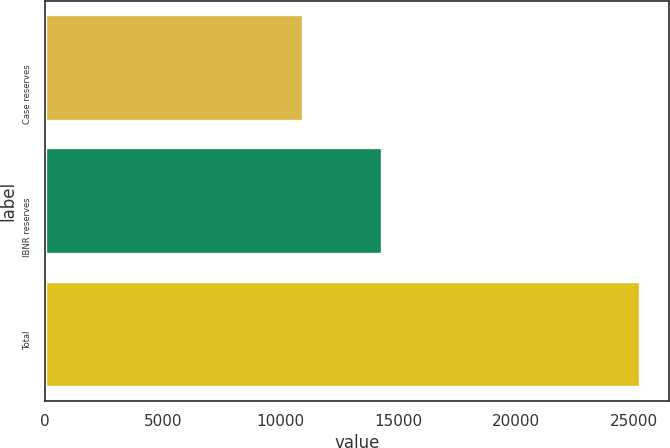<chart> <loc_0><loc_0><loc_500><loc_500><bar_chart><fcel>Case reserves<fcel>IBNR reserves<fcel>Total<nl><fcel>10948<fcel>14294<fcel>25242<nl></chart> 